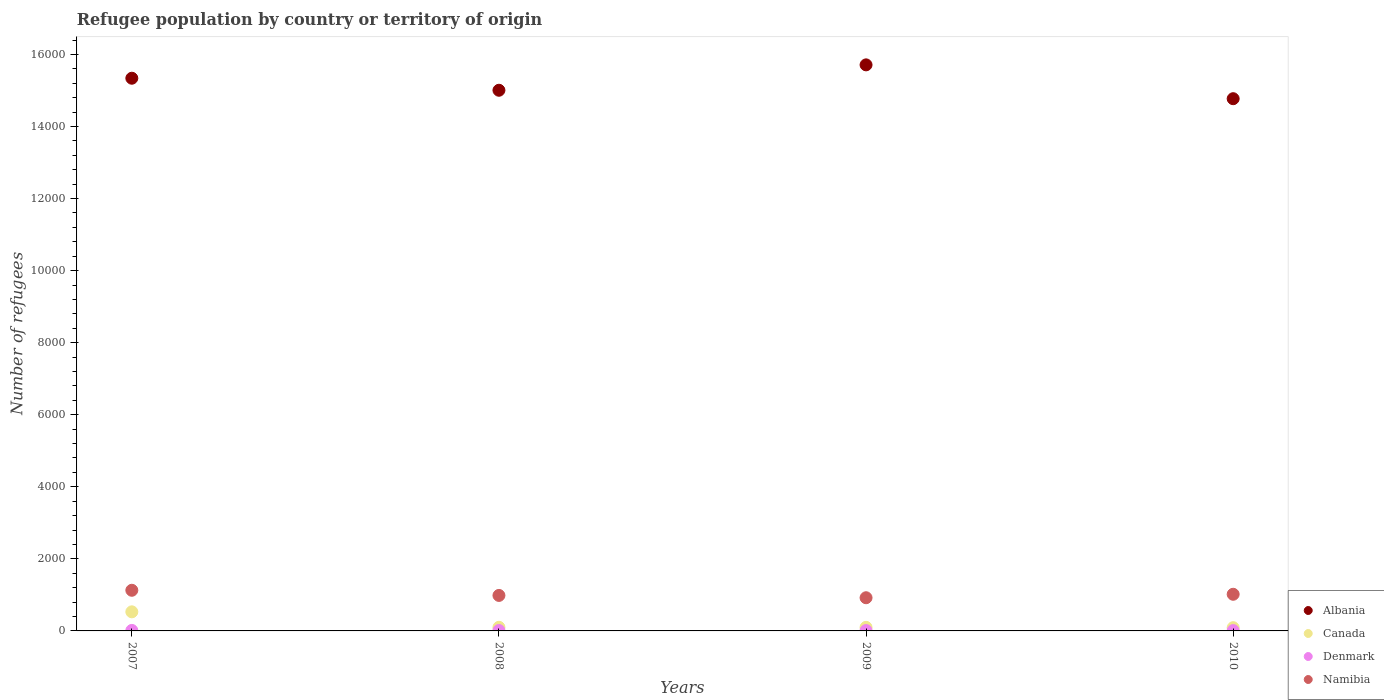What is the number of refugees in Canada in 2007?
Provide a succinct answer. 530. Across all years, what is the maximum number of refugees in Canada?
Your answer should be compact. 530. In which year was the number of refugees in Namibia maximum?
Provide a short and direct response. 2007. In which year was the number of refugees in Namibia minimum?
Your response must be concise. 2009. What is the total number of refugees in Namibia in the graph?
Offer a very short reply. 4051. What is the difference between the number of refugees in Canada in 2007 and that in 2010?
Give a very brief answer. 440. What is the difference between the number of refugees in Canada in 2007 and the number of refugees in Namibia in 2009?
Your answer should be compact. -391. What is the average number of refugees in Denmark per year?
Your response must be concise. 11. In the year 2007, what is the difference between the number of refugees in Albania and number of refugees in Denmark?
Offer a very short reply. 1.53e+04. In how many years, is the number of refugees in Denmark greater than 3200?
Provide a succinct answer. 0. Is the difference between the number of refugees in Albania in 2009 and 2010 greater than the difference between the number of refugees in Denmark in 2009 and 2010?
Offer a very short reply. Yes. What is the difference between the highest and the second highest number of refugees in Namibia?
Offer a very short reply. 111. What is the difference between the highest and the lowest number of refugees in Albania?
Your response must be concise. 939. Is it the case that in every year, the sum of the number of refugees in Canada and number of refugees in Namibia  is greater than the number of refugees in Albania?
Offer a terse response. No. Is the number of refugees in Denmark strictly greater than the number of refugees in Canada over the years?
Your response must be concise. No. Is the number of refugees in Albania strictly less than the number of refugees in Namibia over the years?
Your response must be concise. No. What is the difference between two consecutive major ticks on the Y-axis?
Make the answer very short. 2000. Does the graph contain any zero values?
Make the answer very short. No. Does the graph contain grids?
Your answer should be very brief. No. How many legend labels are there?
Make the answer very short. 4. How are the legend labels stacked?
Make the answer very short. Vertical. What is the title of the graph?
Your answer should be very brief. Refugee population by country or territory of origin. What is the label or title of the X-axis?
Offer a very short reply. Years. What is the label or title of the Y-axis?
Your response must be concise. Number of refugees. What is the Number of refugees of Albania in 2007?
Offer a terse response. 1.53e+04. What is the Number of refugees in Canada in 2007?
Make the answer very short. 530. What is the Number of refugees in Denmark in 2007?
Provide a short and direct response. 14. What is the Number of refugees of Namibia in 2007?
Your response must be concise. 1128. What is the Number of refugees of Albania in 2008?
Provide a short and direct response. 1.50e+04. What is the Number of refugees of Canada in 2008?
Provide a succinct answer. 101. What is the Number of refugees in Denmark in 2008?
Offer a very short reply. 11. What is the Number of refugees in Namibia in 2008?
Offer a terse response. 985. What is the Number of refugees of Albania in 2009?
Keep it short and to the point. 1.57e+04. What is the Number of refugees of Canada in 2009?
Your answer should be very brief. 99. What is the Number of refugees of Namibia in 2009?
Your answer should be compact. 921. What is the Number of refugees in Albania in 2010?
Offer a very short reply. 1.48e+04. What is the Number of refugees of Namibia in 2010?
Your answer should be compact. 1017. Across all years, what is the maximum Number of refugees of Albania?
Your answer should be compact. 1.57e+04. Across all years, what is the maximum Number of refugees of Canada?
Keep it short and to the point. 530. Across all years, what is the maximum Number of refugees in Namibia?
Offer a very short reply. 1128. Across all years, what is the minimum Number of refugees of Albania?
Keep it short and to the point. 1.48e+04. Across all years, what is the minimum Number of refugees in Denmark?
Provide a succinct answer. 9. Across all years, what is the minimum Number of refugees in Namibia?
Make the answer very short. 921. What is the total Number of refugees in Albania in the graph?
Provide a short and direct response. 6.08e+04. What is the total Number of refugees of Canada in the graph?
Your response must be concise. 820. What is the total Number of refugees of Denmark in the graph?
Keep it short and to the point. 44. What is the total Number of refugees in Namibia in the graph?
Offer a terse response. 4051. What is the difference between the Number of refugees of Albania in 2007 and that in 2008?
Make the answer very short. 334. What is the difference between the Number of refugees of Canada in 2007 and that in 2008?
Your answer should be compact. 429. What is the difference between the Number of refugees of Denmark in 2007 and that in 2008?
Give a very brief answer. 3. What is the difference between the Number of refugees of Namibia in 2007 and that in 2008?
Ensure brevity in your answer.  143. What is the difference between the Number of refugees in Albania in 2007 and that in 2009?
Offer a terse response. -371. What is the difference between the Number of refugees in Canada in 2007 and that in 2009?
Provide a succinct answer. 431. What is the difference between the Number of refugees in Denmark in 2007 and that in 2009?
Provide a succinct answer. 4. What is the difference between the Number of refugees in Namibia in 2007 and that in 2009?
Ensure brevity in your answer.  207. What is the difference between the Number of refugees in Albania in 2007 and that in 2010?
Provide a short and direct response. 568. What is the difference between the Number of refugees in Canada in 2007 and that in 2010?
Your answer should be compact. 440. What is the difference between the Number of refugees of Denmark in 2007 and that in 2010?
Offer a terse response. 5. What is the difference between the Number of refugees of Namibia in 2007 and that in 2010?
Provide a succinct answer. 111. What is the difference between the Number of refugees of Albania in 2008 and that in 2009?
Offer a terse response. -705. What is the difference between the Number of refugees of Namibia in 2008 and that in 2009?
Your answer should be compact. 64. What is the difference between the Number of refugees of Albania in 2008 and that in 2010?
Give a very brief answer. 234. What is the difference between the Number of refugees in Canada in 2008 and that in 2010?
Keep it short and to the point. 11. What is the difference between the Number of refugees in Namibia in 2008 and that in 2010?
Give a very brief answer. -32. What is the difference between the Number of refugees in Albania in 2009 and that in 2010?
Your answer should be compact. 939. What is the difference between the Number of refugees of Canada in 2009 and that in 2010?
Your answer should be compact. 9. What is the difference between the Number of refugees in Namibia in 2009 and that in 2010?
Offer a terse response. -96. What is the difference between the Number of refugees of Albania in 2007 and the Number of refugees of Canada in 2008?
Offer a terse response. 1.52e+04. What is the difference between the Number of refugees of Albania in 2007 and the Number of refugees of Denmark in 2008?
Give a very brief answer. 1.53e+04. What is the difference between the Number of refugees of Albania in 2007 and the Number of refugees of Namibia in 2008?
Your answer should be very brief. 1.44e+04. What is the difference between the Number of refugees of Canada in 2007 and the Number of refugees of Denmark in 2008?
Provide a short and direct response. 519. What is the difference between the Number of refugees of Canada in 2007 and the Number of refugees of Namibia in 2008?
Ensure brevity in your answer.  -455. What is the difference between the Number of refugees in Denmark in 2007 and the Number of refugees in Namibia in 2008?
Your response must be concise. -971. What is the difference between the Number of refugees in Albania in 2007 and the Number of refugees in Canada in 2009?
Offer a terse response. 1.52e+04. What is the difference between the Number of refugees in Albania in 2007 and the Number of refugees in Denmark in 2009?
Ensure brevity in your answer.  1.53e+04. What is the difference between the Number of refugees in Albania in 2007 and the Number of refugees in Namibia in 2009?
Your response must be concise. 1.44e+04. What is the difference between the Number of refugees in Canada in 2007 and the Number of refugees in Denmark in 2009?
Your response must be concise. 520. What is the difference between the Number of refugees in Canada in 2007 and the Number of refugees in Namibia in 2009?
Give a very brief answer. -391. What is the difference between the Number of refugees in Denmark in 2007 and the Number of refugees in Namibia in 2009?
Provide a succinct answer. -907. What is the difference between the Number of refugees in Albania in 2007 and the Number of refugees in Canada in 2010?
Keep it short and to the point. 1.52e+04. What is the difference between the Number of refugees in Albania in 2007 and the Number of refugees in Denmark in 2010?
Offer a terse response. 1.53e+04. What is the difference between the Number of refugees in Albania in 2007 and the Number of refugees in Namibia in 2010?
Your answer should be very brief. 1.43e+04. What is the difference between the Number of refugees of Canada in 2007 and the Number of refugees of Denmark in 2010?
Offer a very short reply. 521. What is the difference between the Number of refugees of Canada in 2007 and the Number of refugees of Namibia in 2010?
Offer a very short reply. -487. What is the difference between the Number of refugees in Denmark in 2007 and the Number of refugees in Namibia in 2010?
Keep it short and to the point. -1003. What is the difference between the Number of refugees of Albania in 2008 and the Number of refugees of Canada in 2009?
Give a very brief answer. 1.49e+04. What is the difference between the Number of refugees of Albania in 2008 and the Number of refugees of Denmark in 2009?
Ensure brevity in your answer.  1.50e+04. What is the difference between the Number of refugees of Albania in 2008 and the Number of refugees of Namibia in 2009?
Give a very brief answer. 1.41e+04. What is the difference between the Number of refugees of Canada in 2008 and the Number of refugees of Denmark in 2009?
Ensure brevity in your answer.  91. What is the difference between the Number of refugees in Canada in 2008 and the Number of refugees in Namibia in 2009?
Your answer should be very brief. -820. What is the difference between the Number of refugees of Denmark in 2008 and the Number of refugees of Namibia in 2009?
Make the answer very short. -910. What is the difference between the Number of refugees in Albania in 2008 and the Number of refugees in Canada in 2010?
Your answer should be compact. 1.49e+04. What is the difference between the Number of refugees in Albania in 2008 and the Number of refugees in Denmark in 2010?
Your answer should be very brief. 1.50e+04. What is the difference between the Number of refugees of Albania in 2008 and the Number of refugees of Namibia in 2010?
Give a very brief answer. 1.40e+04. What is the difference between the Number of refugees in Canada in 2008 and the Number of refugees in Denmark in 2010?
Your response must be concise. 92. What is the difference between the Number of refugees in Canada in 2008 and the Number of refugees in Namibia in 2010?
Provide a succinct answer. -916. What is the difference between the Number of refugees in Denmark in 2008 and the Number of refugees in Namibia in 2010?
Your answer should be very brief. -1006. What is the difference between the Number of refugees in Albania in 2009 and the Number of refugees in Canada in 2010?
Make the answer very short. 1.56e+04. What is the difference between the Number of refugees in Albania in 2009 and the Number of refugees in Denmark in 2010?
Your response must be concise. 1.57e+04. What is the difference between the Number of refugees of Albania in 2009 and the Number of refugees of Namibia in 2010?
Make the answer very short. 1.47e+04. What is the difference between the Number of refugees in Canada in 2009 and the Number of refugees in Denmark in 2010?
Keep it short and to the point. 90. What is the difference between the Number of refugees of Canada in 2009 and the Number of refugees of Namibia in 2010?
Keep it short and to the point. -918. What is the difference between the Number of refugees of Denmark in 2009 and the Number of refugees of Namibia in 2010?
Provide a short and direct response. -1007. What is the average Number of refugees in Albania per year?
Provide a succinct answer. 1.52e+04. What is the average Number of refugees of Canada per year?
Your response must be concise. 205. What is the average Number of refugees of Namibia per year?
Offer a very short reply. 1012.75. In the year 2007, what is the difference between the Number of refugees of Albania and Number of refugees of Canada?
Keep it short and to the point. 1.48e+04. In the year 2007, what is the difference between the Number of refugees in Albania and Number of refugees in Denmark?
Offer a terse response. 1.53e+04. In the year 2007, what is the difference between the Number of refugees in Albania and Number of refugees in Namibia?
Provide a succinct answer. 1.42e+04. In the year 2007, what is the difference between the Number of refugees of Canada and Number of refugees of Denmark?
Provide a succinct answer. 516. In the year 2007, what is the difference between the Number of refugees in Canada and Number of refugees in Namibia?
Give a very brief answer. -598. In the year 2007, what is the difference between the Number of refugees in Denmark and Number of refugees in Namibia?
Your response must be concise. -1114. In the year 2008, what is the difference between the Number of refugees in Albania and Number of refugees in Canada?
Offer a very short reply. 1.49e+04. In the year 2008, what is the difference between the Number of refugees in Albania and Number of refugees in Denmark?
Provide a succinct answer. 1.50e+04. In the year 2008, what is the difference between the Number of refugees of Albania and Number of refugees of Namibia?
Keep it short and to the point. 1.40e+04. In the year 2008, what is the difference between the Number of refugees of Canada and Number of refugees of Namibia?
Make the answer very short. -884. In the year 2008, what is the difference between the Number of refugees of Denmark and Number of refugees of Namibia?
Your answer should be compact. -974. In the year 2009, what is the difference between the Number of refugees in Albania and Number of refugees in Canada?
Make the answer very short. 1.56e+04. In the year 2009, what is the difference between the Number of refugees of Albania and Number of refugees of Denmark?
Make the answer very short. 1.57e+04. In the year 2009, what is the difference between the Number of refugees of Albania and Number of refugees of Namibia?
Your answer should be very brief. 1.48e+04. In the year 2009, what is the difference between the Number of refugees of Canada and Number of refugees of Denmark?
Offer a very short reply. 89. In the year 2009, what is the difference between the Number of refugees in Canada and Number of refugees in Namibia?
Provide a short and direct response. -822. In the year 2009, what is the difference between the Number of refugees in Denmark and Number of refugees in Namibia?
Give a very brief answer. -911. In the year 2010, what is the difference between the Number of refugees of Albania and Number of refugees of Canada?
Provide a short and direct response. 1.47e+04. In the year 2010, what is the difference between the Number of refugees in Albania and Number of refugees in Denmark?
Keep it short and to the point. 1.48e+04. In the year 2010, what is the difference between the Number of refugees in Albania and Number of refugees in Namibia?
Ensure brevity in your answer.  1.38e+04. In the year 2010, what is the difference between the Number of refugees of Canada and Number of refugees of Namibia?
Your answer should be very brief. -927. In the year 2010, what is the difference between the Number of refugees in Denmark and Number of refugees in Namibia?
Give a very brief answer. -1008. What is the ratio of the Number of refugees of Albania in 2007 to that in 2008?
Provide a succinct answer. 1.02. What is the ratio of the Number of refugees in Canada in 2007 to that in 2008?
Keep it short and to the point. 5.25. What is the ratio of the Number of refugees in Denmark in 2007 to that in 2008?
Ensure brevity in your answer.  1.27. What is the ratio of the Number of refugees in Namibia in 2007 to that in 2008?
Give a very brief answer. 1.15. What is the ratio of the Number of refugees of Albania in 2007 to that in 2009?
Make the answer very short. 0.98. What is the ratio of the Number of refugees of Canada in 2007 to that in 2009?
Ensure brevity in your answer.  5.35. What is the ratio of the Number of refugees in Namibia in 2007 to that in 2009?
Provide a short and direct response. 1.22. What is the ratio of the Number of refugees in Canada in 2007 to that in 2010?
Provide a succinct answer. 5.89. What is the ratio of the Number of refugees of Denmark in 2007 to that in 2010?
Provide a succinct answer. 1.56. What is the ratio of the Number of refugees of Namibia in 2007 to that in 2010?
Give a very brief answer. 1.11. What is the ratio of the Number of refugees in Albania in 2008 to that in 2009?
Keep it short and to the point. 0.96. What is the ratio of the Number of refugees of Canada in 2008 to that in 2009?
Provide a succinct answer. 1.02. What is the ratio of the Number of refugees in Denmark in 2008 to that in 2009?
Ensure brevity in your answer.  1.1. What is the ratio of the Number of refugees of Namibia in 2008 to that in 2009?
Your answer should be compact. 1.07. What is the ratio of the Number of refugees of Albania in 2008 to that in 2010?
Offer a very short reply. 1.02. What is the ratio of the Number of refugees in Canada in 2008 to that in 2010?
Ensure brevity in your answer.  1.12. What is the ratio of the Number of refugees in Denmark in 2008 to that in 2010?
Keep it short and to the point. 1.22. What is the ratio of the Number of refugees of Namibia in 2008 to that in 2010?
Make the answer very short. 0.97. What is the ratio of the Number of refugees of Albania in 2009 to that in 2010?
Keep it short and to the point. 1.06. What is the ratio of the Number of refugees in Namibia in 2009 to that in 2010?
Your response must be concise. 0.91. What is the difference between the highest and the second highest Number of refugees of Albania?
Offer a very short reply. 371. What is the difference between the highest and the second highest Number of refugees in Canada?
Make the answer very short. 429. What is the difference between the highest and the second highest Number of refugees of Namibia?
Your response must be concise. 111. What is the difference between the highest and the lowest Number of refugees of Albania?
Provide a succinct answer. 939. What is the difference between the highest and the lowest Number of refugees of Canada?
Your answer should be very brief. 440. What is the difference between the highest and the lowest Number of refugees in Namibia?
Offer a very short reply. 207. 